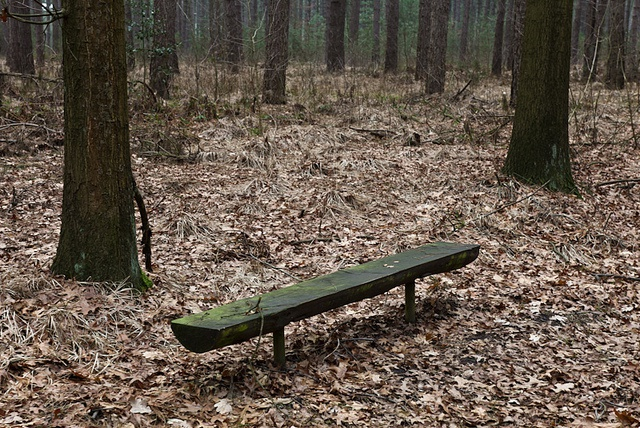Describe the objects in this image and their specific colors. I can see a bench in darkgreen, black, gray, and olive tones in this image. 